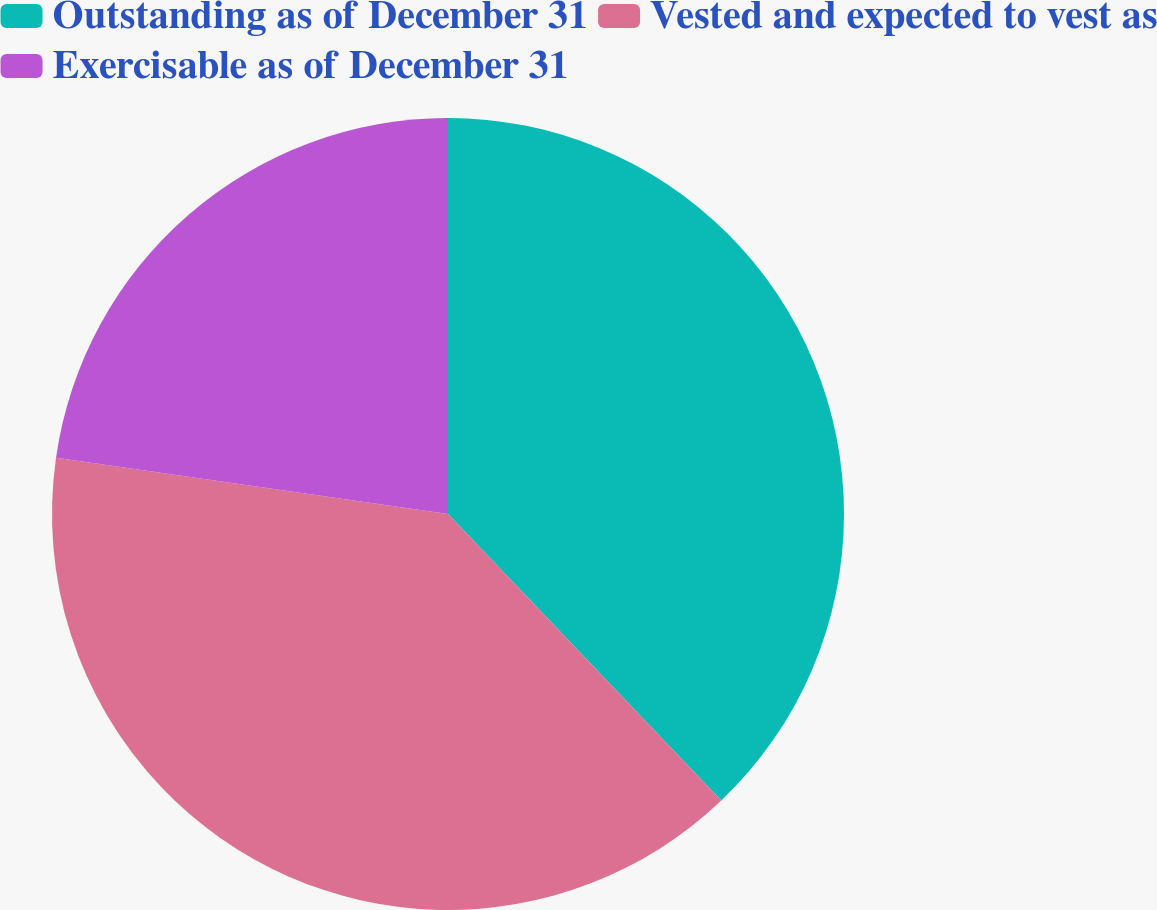<chart> <loc_0><loc_0><loc_500><loc_500><pie_chart><fcel>Outstanding as of December 31<fcel>Vested and expected to vest as<fcel>Exercisable as of December 31<nl><fcel>37.88%<fcel>39.39%<fcel>22.73%<nl></chart> 